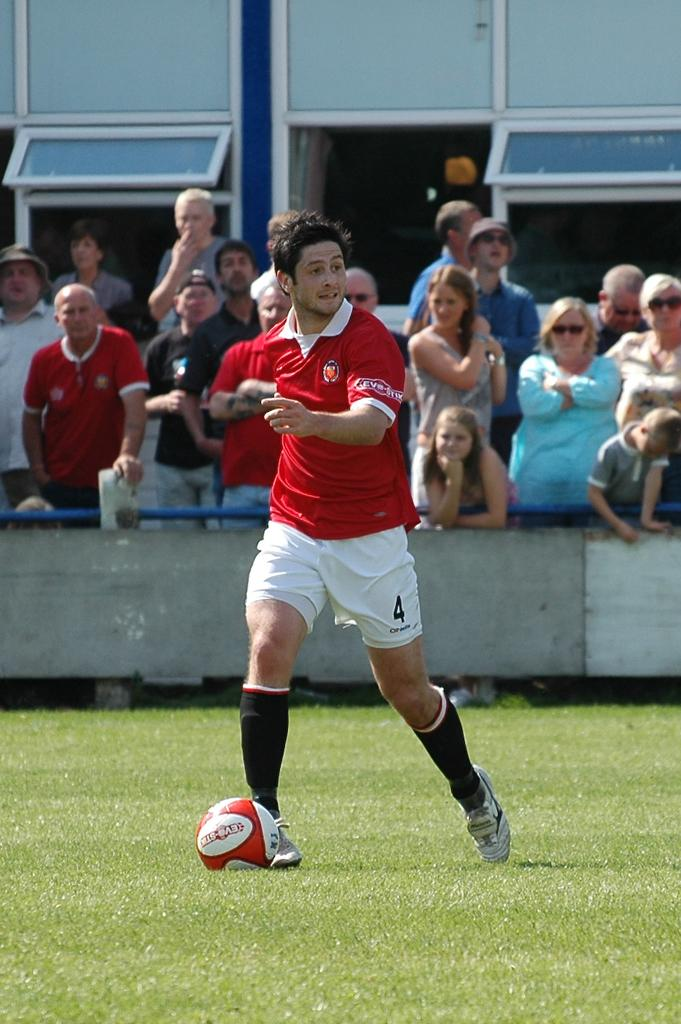What is the occupation of the person in the image? The person in the image is a sports player. What color is the shirt the sports player is wearing? The sports player is wearing a red color shirt. What color are the shorts the sports player is wearing? The sports player is wearing white shorts. Where is the sports player located in the image? The sports player is on the pitch. What are the people behind the sports player doing? The people are standing behind the sports player and watching him. What type of dust can be seen on the edge of the sports player's shoes in the image? There is no dust visible on the sports player's shoes in the image. 